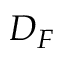<formula> <loc_0><loc_0><loc_500><loc_500>D _ { F }</formula> 